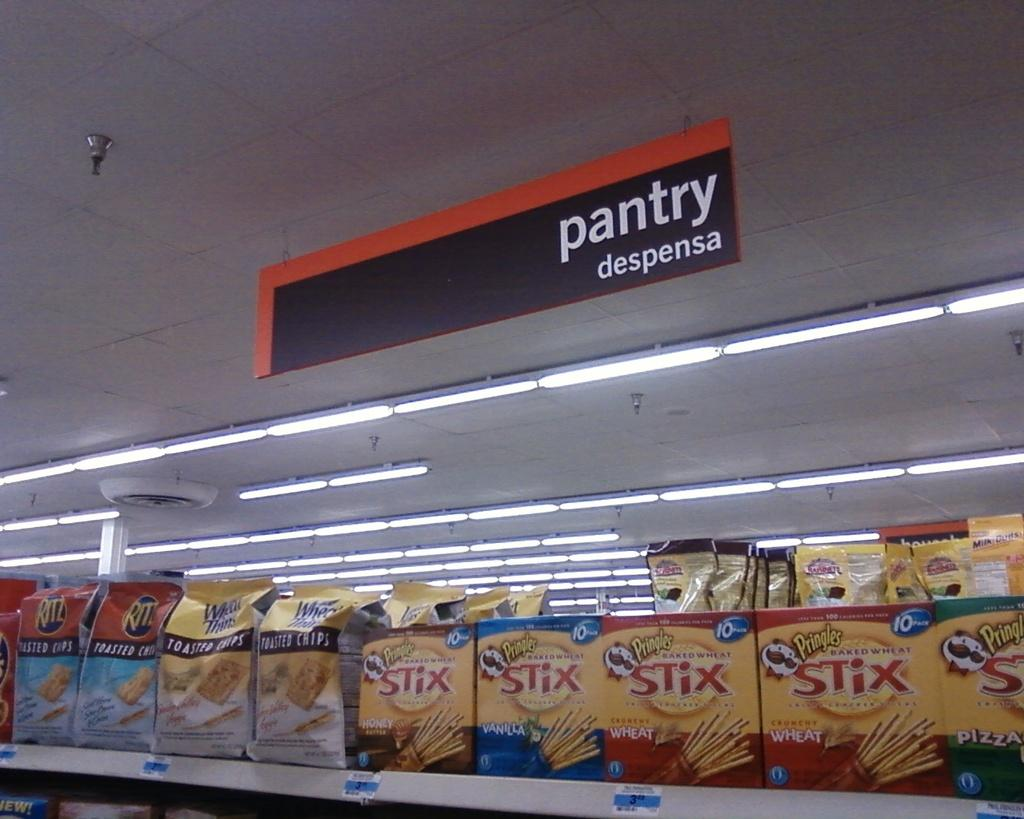What is the perspective of the image? The image is taken from inside. What can be seen on the rack in the image? There are food items placed in a rack. What is visible on the ceiling in the image? There are lights visible on the ceiling. What is located at the top of the image? There is a board at the top of the image. What is the name of the moon visible in the image? There is no moon visible in the image; it is taken from inside and shows a rack with food items, a ceiling with lights, and a board at the top. 